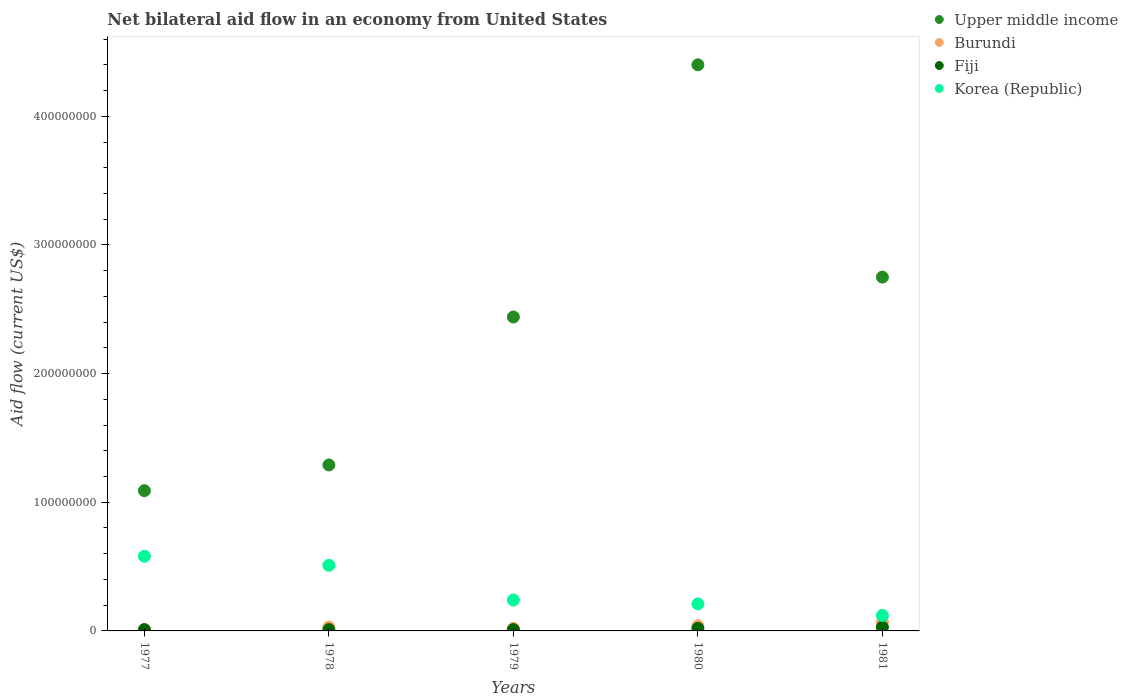How many different coloured dotlines are there?
Offer a terse response. 4. Is the number of dotlines equal to the number of legend labels?
Give a very brief answer. Yes. What is the difference between the net bilateral aid flow in Upper middle income in 1977 and that in 1980?
Provide a succinct answer. -3.31e+08. What is the difference between the net bilateral aid flow in Fiji in 1978 and the net bilateral aid flow in Upper middle income in 1980?
Provide a short and direct response. -4.39e+08. What is the average net bilateral aid flow in Upper middle income per year?
Provide a succinct answer. 2.39e+08. In the year 1978, what is the difference between the net bilateral aid flow in Upper middle income and net bilateral aid flow in Korea (Republic)?
Provide a succinct answer. 7.80e+07. In how many years, is the net bilateral aid flow in Korea (Republic) greater than 80000000 US$?
Your answer should be compact. 0. What is the ratio of the net bilateral aid flow in Korea (Republic) in 1978 to that in 1979?
Your response must be concise. 2.12. Is the net bilateral aid flow in Burundi in 1979 less than that in 1980?
Offer a terse response. Yes. Is the difference between the net bilateral aid flow in Upper middle income in 1979 and 1981 greater than the difference between the net bilateral aid flow in Korea (Republic) in 1979 and 1981?
Your response must be concise. No. What is the difference between the highest and the second highest net bilateral aid flow in Fiji?
Your answer should be compact. 1.00e+06. What is the difference between the highest and the lowest net bilateral aid flow in Korea (Republic)?
Ensure brevity in your answer.  4.60e+07. In how many years, is the net bilateral aid flow in Fiji greater than the average net bilateral aid flow in Fiji taken over all years?
Offer a very short reply. 2. Is the sum of the net bilateral aid flow in Burundi in 1977 and 1978 greater than the maximum net bilateral aid flow in Upper middle income across all years?
Keep it short and to the point. No. Is it the case that in every year, the sum of the net bilateral aid flow in Fiji and net bilateral aid flow in Upper middle income  is greater than the net bilateral aid flow in Korea (Republic)?
Provide a succinct answer. Yes. Is the net bilateral aid flow in Fiji strictly greater than the net bilateral aid flow in Burundi over the years?
Provide a short and direct response. No. Is the net bilateral aid flow in Fiji strictly less than the net bilateral aid flow in Korea (Republic) over the years?
Keep it short and to the point. Yes. How many dotlines are there?
Make the answer very short. 4. How many years are there in the graph?
Your answer should be compact. 5. What is the difference between two consecutive major ticks on the Y-axis?
Your response must be concise. 1.00e+08. Does the graph contain grids?
Keep it short and to the point. No. Where does the legend appear in the graph?
Provide a short and direct response. Top right. How many legend labels are there?
Provide a succinct answer. 4. How are the legend labels stacked?
Provide a short and direct response. Vertical. What is the title of the graph?
Offer a terse response. Net bilateral aid flow in an economy from United States. Does "Euro area" appear as one of the legend labels in the graph?
Your response must be concise. No. What is the label or title of the Y-axis?
Offer a terse response. Aid flow (current US$). What is the Aid flow (current US$) of Upper middle income in 1977?
Provide a succinct answer. 1.09e+08. What is the Aid flow (current US$) in Fiji in 1977?
Keep it short and to the point. 1.00e+06. What is the Aid flow (current US$) in Korea (Republic) in 1977?
Give a very brief answer. 5.80e+07. What is the Aid flow (current US$) of Upper middle income in 1978?
Ensure brevity in your answer.  1.29e+08. What is the Aid flow (current US$) in Burundi in 1978?
Offer a very short reply. 3.00e+06. What is the Aid flow (current US$) in Korea (Republic) in 1978?
Offer a very short reply. 5.10e+07. What is the Aid flow (current US$) in Upper middle income in 1979?
Keep it short and to the point. 2.44e+08. What is the Aid flow (current US$) in Burundi in 1979?
Keep it short and to the point. 2.00e+06. What is the Aid flow (current US$) in Korea (Republic) in 1979?
Your answer should be very brief. 2.40e+07. What is the Aid flow (current US$) in Upper middle income in 1980?
Ensure brevity in your answer.  4.40e+08. What is the Aid flow (current US$) in Fiji in 1980?
Make the answer very short. 2.00e+06. What is the Aid flow (current US$) of Korea (Republic) in 1980?
Provide a short and direct response. 2.10e+07. What is the Aid flow (current US$) of Upper middle income in 1981?
Ensure brevity in your answer.  2.75e+08. What is the Aid flow (current US$) of Burundi in 1981?
Make the answer very short. 7.00e+06. What is the Aid flow (current US$) of Fiji in 1981?
Provide a short and direct response. 3.00e+06. What is the Aid flow (current US$) in Korea (Republic) in 1981?
Provide a succinct answer. 1.20e+07. Across all years, what is the maximum Aid flow (current US$) of Upper middle income?
Provide a short and direct response. 4.40e+08. Across all years, what is the maximum Aid flow (current US$) in Korea (Republic)?
Your answer should be very brief. 5.80e+07. Across all years, what is the minimum Aid flow (current US$) of Upper middle income?
Keep it short and to the point. 1.09e+08. Across all years, what is the minimum Aid flow (current US$) in Korea (Republic)?
Your answer should be compact. 1.20e+07. What is the total Aid flow (current US$) of Upper middle income in the graph?
Your response must be concise. 1.20e+09. What is the total Aid flow (current US$) of Burundi in the graph?
Offer a terse response. 1.70e+07. What is the total Aid flow (current US$) of Korea (Republic) in the graph?
Your answer should be compact. 1.66e+08. What is the difference between the Aid flow (current US$) in Upper middle income in 1977 and that in 1978?
Your response must be concise. -2.00e+07. What is the difference between the Aid flow (current US$) in Burundi in 1977 and that in 1978?
Make the answer very short. -2.00e+06. What is the difference between the Aid flow (current US$) of Fiji in 1977 and that in 1978?
Make the answer very short. 0. What is the difference between the Aid flow (current US$) in Upper middle income in 1977 and that in 1979?
Your response must be concise. -1.35e+08. What is the difference between the Aid flow (current US$) in Burundi in 1977 and that in 1979?
Make the answer very short. -1.00e+06. What is the difference between the Aid flow (current US$) of Fiji in 1977 and that in 1979?
Your response must be concise. 0. What is the difference between the Aid flow (current US$) in Korea (Republic) in 1977 and that in 1979?
Offer a very short reply. 3.40e+07. What is the difference between the Aid flow (current US$) in Upper middle income in 1977 and that in 1980?
Your response must be concise. -3.31e+08. What is the difference between the Aid flow (current US$) of Burundi in 1977 and that in 1980?
Provide a short and direct response. -3.00e+06. What is the difference between the Aid flow (current US$) of Korea (Republic) in 1977 and that in 1980?
Offer a terse response. 3.70e+07. What is the difference between the Aid flow (current US$) of Upper middle income in 1977 and that in 1981?
Offer a very short reply. -1.66e+08. What is the difference between the Aid flow (current US$) in Burundi in 1977 and that in 1981?
Your response must be concise. -6.00e+06. What is the difference between the Aid flow (current US$) in Korea (Republic) in 1977 and that in 1981?
Offer a terse response. 4.60e+07. What is the difference between the Aid flow (current US$) in Upper middle income in 1978 and that in 1979?
Keep it short and to the point. -1.15e+08. What is the difference between the Aid flow (current US$) of Korea (Republic) in 1978 and that in 1979?
Offer a terse response. 2.70e+07. What is the difference between the Aid flow (current US$) of Upper middle income in 1978 and that in 1980?
Give a very brief answer. -3.11e+08. What is the difference between the Aid flow (current US$) of Korea (Republic) in 1978 and that in 1980?
Provide a succinct answer. 3.00e+07. What is the difference between the Aid flow (current US$) of Upper middle income in 1978 and that in 1981?
Make the answer very short. -1.46e+08. What is the difference between the Aid flow (current US$) of Fiji in 1978 and that in 1981?
Provide a succinct answer. -2.00e+06. What is the difference between the Aid flow (current US$) of Korea (Republic) in 1978 and that in 1981?
Ensure brevity in your answer.  3.90e+07. What is the difference between the Aid flow (current US$) in Upper middle income in 1979 and that in 1980?
Ensure brevity in your answer.  -1.96e+08. What is the difference between the Aid flow (current US$) of Korea (Republic) in 1979 and that in 1980?
Give a very brief answer. 3.00e+06. What is the difference between the Aid flow (current US$) in Upper middle income in 1979 and that in 1981?
Ensure brevity in your answer.  -3.10e+07. What is the difference between the Aid flow (current US$) in Burundi in 1979 and that in 1981?
Your response must be concise. -5.00e+06. What is the difference between the Aid flow (current US$) of Fiji in 1979 and that in 1981?
Your response must be concise. -2.00e+06. What is the difference between the Aid flow (current US$) in Korea (Republic) in 1979 and that in 1981?
Ensure brevity in your answer.  1.20e+07. What is the difference between the Aid flow (current US$) in Upper middle income in 1980 and that in 1981?
Your response must be concise. 1.65e+08. What is the difference between the Aid flow (current US$) of Burundi in 1980 and that in 1981?
Provide a succinct answer. -3.00e+06. What is the difference between the Aid flow (current US$) in Fiji in 1980 and that in 1981?
Your answer should be very brief. -1.00e+06. What is the difference between the Aid flow (current US$) in Korea (Republic) in 1980 and that in 1981?
Make the answer very short. 9.00e+06. What is the difference between the Aid flow (current US$) of Upper middle income in 1977 and the Aid flow (current US$) of Burundi in 1978?
Offer a very short reply. 1.06e+08. What is the difference between the Aid flow (current US$) in Upper middle income in 1977 and the Aid flow (current US$) in Fiji in 1978?
Ensure brevity in your answer.  1.08e+08. What is the difference between the Aid flow (current US$) in Upper middle income in 1977 and the Aid flow (current US$) in Korea (Republic) in 1978?
Provide a short and direct response. 5.80e+07. What is the difference between the Aid flow (current US$) in Burundi in 1977 and the Aid flow (current US$) in Korea (Republic) in 1978?
Provide a short and direct response. -5.00e+07. What is the difference between the Aid flow (current US$) in Fiji in 1977 and the Aid flow (current US$) in Korea (Republic) in 1978?
Your answer should be compact. -5.00e+07. What is the difference between the Aid flow (current US$) of Upper middle income in 1977 and the Aid flow (current US$) of Burundi in 1979?
Give a very brief answer. 1.07e+08. What is the difference between the Aid flow (current US$) of Upper middle income in 1977 and the Aid flow (current US$) of Fiji in 1979?
Give a very brief answer. 1.08e+08. What is the difference between the Aid flow (current US$) in Upper middle income in 1977 and the Aid flow (current US$) in Korea (Republic) in 1979?
Offer a terse response. 8.50e+07. What is the difference between the Aid flow (current US$) in Burundi in 1977 and the Aid flow (current US$) in Fiji in 1979?
Your response must be concise. 0. What is the difference between the Aid flow (current US$) in Burundi in 1977 and the Aid flow (current US$) in Korea (Republic) in 1979?
Ensure brevity in your answer.  -2.30e+07. What is the difference between the Aid flow (current US$) in Fiji in 1977 and the Aid flow (current US$) in Korea (Republic) in 1979?
Your answer should be compact. -2.30e+07. What is the difference between the Aid flow (current US$) in Upper middle income in 1977 and the Aid flow (current US$) in Burundi in 1980?
Provide a succinct answer. 1.05e+08. What is the difference between the Aid flow (current US$) of Upper middle income in 1977 and the Aid flow (current US$) of Fiji in 1980?
Ensure brevity in your answer.  1.07e+08. What is the difference between the Aid flow (current US$) of Upper middle income in 1977 and the Aid flow (current US$) of Korea (Republic) in 1980?
Give a very brief answer. 8.80e+07. What is the difference between the Aid flow (current US$) of Burundi in 1977 and the Aid flow (current US$) of Korea (Republic) in 1980?
Ensure brevity in your answer.  -2.00e+07. What is the difference between the Aid flow (current US$) in Fiji in 1977 and the Aid flow (current US$) in Korea (Republic) in 1980?
Provide a succinct answer. -2.00e+07. What is the difference between the Aid flow (current US$) of Upper middle income in 1977 and the Aid flow (current US$) of Burundi in 1981?
Provide a succinct answer. 1.02e+08. What is the difference between the Aid flow (current US$) of Upper middle income in 1977 and the Aid flow (current US$) of Fiji in 1981?
Your answer should be compact. 1.06e+08. What is the difference between the Aid flow (current US$) of Upper middle income in 1977 and the Aid flow (current US$) of Korea (Republic) in 1981?
Give a very brief answer. 9.70e+07. What is the difference between the Aid flow (current US$) of Burundi in 1977 and the Aid flow (current US$) of Korea (Republic) in 1981?
Your response must be concise. -1.10e+07. What is the difference between the Aid flow (current US$) in Fiji in 1977 and the Aid flow (current US$) in Korea (Republic) in 1981?
Provide a short and direct response. -1.10e+07. What is the difference between the Aid flow (current US$) in Upper middle income in 1978 and the Aid flow (current US$) in Burundi in 1979?
Ensure brevity in your answer.  1.27e+08. What is the difference between the Aid flow (current US$) in Upper middle income in 1978 and the Aid flow (current US$) in Fiji in 1979?
Offer a terse response. 1.28e+08. What is the difference between the Aid flow (current US$) in Upper middle income in 1978 and the Aid flow (current US$) in Korea (Republic) in 1979?
Ensure brevity in your answer.  1.05e+08. What is the difference between the Aid flow (current US$) in Burundi in 1978 and the Aid flow (current US$) in Fiji in 1979?
Your answer should be very brief. 2.00e+06. What is the difference between the Aid flow (current US$) in Burundi in 1978 and the Aid flow (current US$) in Korea (Republic) in 1979?
Provide a short and direct response. -2.10e+07. What is the difference between the Aid flow (current US$) of Fiji in 1978 and the Aid flow (current US$) of Korea (Republic) in 1979?
Ensure brevity in your answer.  -2.30e+07. What is the difference between the Aid flow (current US$) in Upper middle income in 1978 and the Aid flow (current US$) in Burundi in 1980?
Your answer should be very brief. 1.25e+08. What is the difference between the Aid flow (current US$) in Upper middle income in 1978 and the Aid flow (current US$) in Fiji in 1980?
Ensure brevity in your answer.  1.27e+08. What is the difference between the Aid flow (current US$) of Upper middle income in 1978 and the Aid flow (current US$) of Korea (Republic) in 1980?
Your answer should be very brief. 1.08e+08. What is the difference between the Aid flow (current US$) of Burundi in 1978 and the Aid flow (current US$) of Fiji in 1980?
Provide a short and direct response. 1.00e+06. What is the difference between the Aid flow (current US$) of Burundi in 1978 and the Aid flow (current US$) of Korea (Republic) in 1980?
Make the answer very short. -1.80e+07. What is the difference between the Aid flow (current US$) in Fiji in 1978 and the Aid flow (current US$) in Korea (Republic) in 1980?
Give a very brief answer. -2.00e+07. What is the difference between the Aid flow (current US$) of Upper middle income in 1978 and the Aid flow (current US$) of Burundi in 1981?
Your response must be concise. 1.22e+08. What is the difference between the Aid flow (current US$) of Upper middle income in 1978 and the Aid flow (current US$) of Fiji in 1981?
Your response must be concise. 1.26e+08. What is the difference between the Aid flow (current US$) of Upper middle income in 1978 and the Aid flow (current US$) of Korea (Republic) in 1981?
Your answer should be compact. 1.17e+08. What is the difference between the Aid flow (current US$) in Burundi in 1978 and the Aid flow (current US$) in Korea (Republic) in 1981?
Give a very brief answer. -9.00e+06. What is the difference between the Aid flow (current US$) of Fiji in 1978 and the Aid flow (current US$) of Korea (Republic) in 1981?
Provide a short and direct response. -1.10e+07. What is the difference between the Aid flow (current US$) of Upper middle income in 1979 and the Aid flow (current US$) of Burundi in 1980?
Offer a very short reply. 2.40e+08. What is the difference between the Aid flow (current US$) of Upper middle income in 1979 and the Aid flow (current US$) of Fiji in 1980?
Provide a short and direct response. 2.42e+08. What is the difference between the Aid flow (current US$) of Upper middle income in 1979 and the Aid flow (current US$) of Korea (Republic) in 1980?
Make the answer very short. 2.23e+08. What is the difference between the Aid flow (current US$) in Burundi in 1979 and the Aid flow (current US$) in Fiji in 1980?
Keep it short and to the point. 0. What is the difference between the Aid flow (current US$) of Burundi in 1979 and the Aid flow (current US$) of Korea (Republic) in 1980?
Offer a terse response. -1.90e+07. What is the difference between the Aid flow (current US$) of Fiji in 1979 and the Aid flow (current US$) of Korea (Republic) in 1980?
Your answer should be compact. -2.00e+07. What is the difference between the Aid flow (current US$) in Upper middle income in 1979 and the Aid flow (current US$) in Burundi in 1981?
Your answer should be very brief. 2.37e+08. What is the difference between the Aid flow (current US$) in Upper middle income in 1979 and the Aid flow (current US$) in Fiji in 1981?
Your answer should be very brief. 2.41e+08. What is the difference between the Aid flow (current US$) of Upper middle income in 1979 and the Aid flow (current US$) of Korea (Republic) in 1981?
Make the answer very short. 2.32e+08. What is the difference between the Aid flow (current US$) in Burundi in 1979 and the Aid flow (current US$) in Fiji in 1981?
Ensure brevity in your answer.  -1.00e+06. What is the difference between the Aid flow (current US$) in Burundi in 1979 and the Aid flow (current US$) in Korea (Republic) in 1981?
Give a very brief answer. -1.00e+07. What is the difference between the Aid flow (current US$) in Fiji in 1979 and the Aid flow (current US$) in Korea (Republic) in 1981?
Make the answer very short. -1.10e+07. What is the difference between the Aid flow (current US$) of Upper middle income in 1980 and the Aid flow (current US$) of Burundi in 1981?
Your answer should be very brief. 4.33e+08. What is the difference between the Aid flow (current US$) in Upper middle income in 1980 and the Aid flow (current US$) in Fiji in 1981?
Provide a succinct answer. 4.37e+08. What is the difference between the Aid flow (current US$) of Upper middle income in 1980 and the Aid flow (current US$) of Korea (Republic) in 1981?
Ensure brevity in your answer.  4.28e+08. What is the difference between the Aid flow (current US$) in Burundi in 1980 and the Aid flow (current US$) in Fiji in 1981?
Your answer should be compact. 1.00e+06. What is the difference between the Aid flow (current US$) of Burundi in 1980 and the Aid flow (current US$) of Korea (Republic) in 1981?
Give a very brief answer. -8.00e+06. What is the difference between the Aid flow (current US$) in Fiji in 1980 and the Aid flow (current US$) in Korea (Republic) in 1981?
Offer a very short reply. -1.00e+07. What is the average Aid flow (current US$) of Upper middle income per year?
Provide a succinct answer. 2.39e+08. What is the average Aid flow (current US$) of Burundi per year?
Provide a short and direct response. 3.40e+06. What is the average Aid flow (current US$) in Fiji per year?
Provide a short and direct response. 1.60e+06. What is the average Aid flow (current US$) in Korea (Republic) per year?
Give a very brief answer. 3.32e+07. In the year 1977, what is the difference between the Aid flow (current US$) of Upper middle income and Aid flow (current US$) of Burundi?
Provide a short and direct response. 1.08e+08. In the year 1977, what is the difference between the Aid flow (current US$) of Upper middle income and Aid flow (current US$) of Fiji?
Your answer should be very brief. 1.08e+08. In the year 1977, what is the difference between the Aid flow (current US$) of Upper middle income and Aid flow (current US$) of Korea (Republic)?
Provide a short and direct response. 5.10e+07. In the year 1977, what is the difference between the Aid flow (current US$) of Burundi and Aid flow (current US$) of Korea (Republic)?
Offer a terse response. -5.70e+07. In the year 1977, what is the difference between the Aid flow (current US$) in Fiji and Aid flow (current US$) in Korea (Republic)?
Offer a terse response. -5.70e+07. In the year 1978, what is the difference between the Aid flow (current US$) in Upper middle income and Aid flow (current US$) in Burundi?
Offer a terse response. 1.26e+08. In the year 1978, what is the difference between the Aid flow (current US$) in Upper middle income and Aid flow (current US$) in Fiji?
Provide a short and direct response. 1.28e+08. In the year 1978, what is the difference between the Aid flow (current US$) in Upper middle income and Aid flow (current US$) in Korea (Republic)?
Keep it short and to the point. 7.80e+07. In the year 1978, what is the difference between the Aid flow (current US$) of Burundi and Aid flow (current US$) of Korea (Republic)?
Provide a succinct answer. -4.80e+07. In the year 1978, what is the difference between the Aid flow (current US$) in Fiji and Aid flow (current US$) in Korea (Republic)?
Your answer should be compact. -5.00e+07. In the year 1979, what is the difference between the Aid flow (current US$) in Upper middle income and Aid flow (current US$) in Burundi?
Give a very brief answer. 2.42e+08. In the year 1979, what is the difference between the Aid flow (current US$) of Upper middle income and Aid flow (current US$) of Fiji?
Give a very brief answer. 2.43e+08. In the year 1979, what is the difference between the Aid flow (current US$) of Upper middle income and Aid flow (current US$) of Korea (Republic)?
Your answer should be very brief. 2.20e+08. In the year 1979, what is the difference between the Aid flow (current US$) in Burundi and Aid flow (current US$) in Fiji?
Make the answer very short. 1.00e+06. In the year 1979, what is the difference between the Aid flow (current US$) of Burundi and Aid flow (current US$) of Korea (Republic)?
Make the answer very short. -2.20e+07. In the year 1979, what is the difference between the Aid flow (current US$) of Fiji and Aid flow (current US$) of Korea (Republic)?
Your response must be concise. -2.30e+07. In the year 1980, what is the difference between the Aid flow (current US$) in Upper middle income and Aid flow (current US$) in Burundi?
Offer a very short reply. 4.36e+08. In the year 1980, what is the difference between the Aid flow (current US$) of Upper middle income and Aid flow (current US$) of Fiji?
Provide a succinct answer. 4.38e+08. In the year 1980, what is the difference between the Aid flow (current US$) in Upper middle income and Aid flow (current US$) in Korea (Republic)?
Your answer should be compact. 4.19e+08. In the year 1980, what is the difference between the Aid flow (current US$) of Burundi and Aid flow (current US$) of Korea (Republic)?
Your answer should be compact. -1.70e+07. In the year 1980, what is the difference between the Aid flow (current US$) in Fiji and Aid flow (current US$) in Korea (Republic)?
Provide a succinct answer. -1.90e+07. In the year 1981, what is the difference between the Aid flow (current US$) of Upper middle income and Aid flow (current US$) of Burundi?
Your answer should be compact. 2.68e+08. In the year 1981, what is the difference between the Aid flow (current US$) of Upper middle income and Aid flow (current US$) of Fiji?
Offer a terse response. 2.72e+08. In the year 1981, what is the difference between the Aid flow (current US$) in Upper middle income and Aid flow (current US$) in Korea (Republic)?
Your response must be concise. 2.63e+08. In the year 1981, what is the difference between the Aid flow (current US$) in Burundi and Aid flow (current US$) in Korea (Republic)?
Your response must be concise. -5.00e+06. In the year 1981, what is the difference between the Aid flow (current US$) of Fiji and Aid flow (current US$) of Korea (Republic)?
Keep it short and to the point. -9.00e+06. What is the ratio of the Aid flow (current US$) of Upper middle income in 1977 to that in 1978?
Give a very brief answer. 0.84. What is the ratio of the Aid flow (current US$) of Burundi in 1977 to that in 1978?
Offer a terse response. 0.33. What is the ratio of the Aid flow (current US$) in Fiji in 1977 to that in 1978?
Your response must be concise. 1. What is the ratio of the Aid flow (current US$) of Korea (Republic) in 1977 to that in 1978?
Provide a short and direct response. 1.14. What is the ratio of the Aid flow (current US$) of Upper middle income in 1977 to that in 1979?
Ensure brevity in your answer.  0.45. What is the ratio of the Aid flow (current US$) in Burundi in 1977 to that in 1979?
Give a very brief answer. 0.5. What is the ratio of the Aid flow (current US$) in Fiji in 1977 to that in 1979?
Give a very brief answer. 1. What is the ratio of the Aid flow (current US$) of Korea (Republic) in 1977 to that in 1979?
Give a very brief answer. 2.42. What is the ratio of the Aid flow (current US$) in Upper middle income in 1977 to that in 1980?
Your response must be concise. 0.25. What is the ratio of the Aid flow (current US$) in Korea (Republic) in 1977 to that in 1980?
Give a very brief answer. 2.76. What is the ratio of the Aid flow (current US$) of Upper middle income in 1977 to that in 1981?
Your answer should be very brief. 0.4. What is the ratio of the Aid flow (current US$) of Burundi in 1977 to that in 1981?
Provide a short and direct response. 0.14. What is the ratio of the Aid flow (current US$) in Korea (Republic) in 1977 to that in 1981?
Your answer should be very brief. 4.83. What is the ratio of the Aid flow (current US$) of Upper middle income in 1978 to that in 1979?
Provide a succinct answer. 0.53. What is the ratio of the Aid flow (current US$) of Burundi in 1978 to that in 1979?
Provide a short and direct response. 1.5. What is the ratio of the Aid flow (current US$) of Korea (Republic) in 1978 to that in 1979?
Your response must be concise. 2.12. What is the ratio of the Aid flow (current US$) of Upper middle income in 1978 to that in 1980?
Give a very brief answer. 0.29. What is the ratio of the Aid flow (current US$) in Burundi in 1978 to that in 1980?
Ensure brevity in your answer.  0.75. What is the ratio of the Aid flow (current US$) of Korea (Republic) in 1978 to that in 1980?
Your answer should be compact. 2.43. What is the ratio of the Aid flow (current US$) of Upper middle income in 1978 to that in 1981?
Give a very brief answer. 0.47. What is the ratio of the Aid flow (current US$) in Burundi in 1978 to that in 1981?
Provide a short and direct response. 0.43. What is the ratio of the Aid flow (current US$) in Fiji in 1978 to that in 1981?
Your answer should be compact. 0.33. What is the ratio of the Aid flow (current US$) of Korea (Republic) in 1978 to that in 1981?
Keep it short and to the point. 4.25. What is the ratio of the Aid flow (current US$) in Upper middle income in 1979 to that in 1980?
Your answer should be very brief. 0.55. What is the ratio of the Aid flow (current US$) in Burundi in 1979 to that in 1980?
Your answer should be compact. 0.5. What is the ratio of the Aid flow (current US$) in Fiji in 1979 to that in 1980?
Offer a terse response. 0.5. What is the ratio of the Aid flow (current US$) of Korea (Republic) in 1979 to that in 1980?
Offer a very short reply. 1.14. What is the ratio of the Aid flow (current US$) of Upper middle income in 1979 to that in 1981?
Offer a terse response. 0.89. What is the ratio of the Aid flow (current US$) of Burundi in 1979 to that in 1981?
Keep it short and to the point. 0.29. What is the ratio of the Aid flow (current US$) of Upper middle income in 1980 to that in 1981?
Make the answer very short. 1.6. What is the ratio of the Aid flow (current US$) in Korea (Republic) in 1980 to that in 1981?
Keep it short and to the point. 1.75. What is the difference between the highest and the second highest Aid flow (current US$) of Upper middle income?
Ensure brevity in your answer.  1.65e+08. What is the difference between the highest and the second highest Aid flow (current US$) in Fiji?
Your answer should be compact. 1.00e+06. What is the difference between the highest and the second highest Aid flow (current US$) in Korea (Republic)?
Your answer should be compact. 7.00e+06. What is the difference between the highest and the lowest Aid flow (current US$) of Upper middle income?
Your answer should be very brief. 3.31e+08. What is the difference between the highest and the lowest Aid flow (current US$) of Fiji?
Offer a very short reply. 2.00e+06. What is the difference between the highest and the lowest Aid flow (current US$) of Korea (Republic)?
Give a very brief answer. 4.60e+07. 